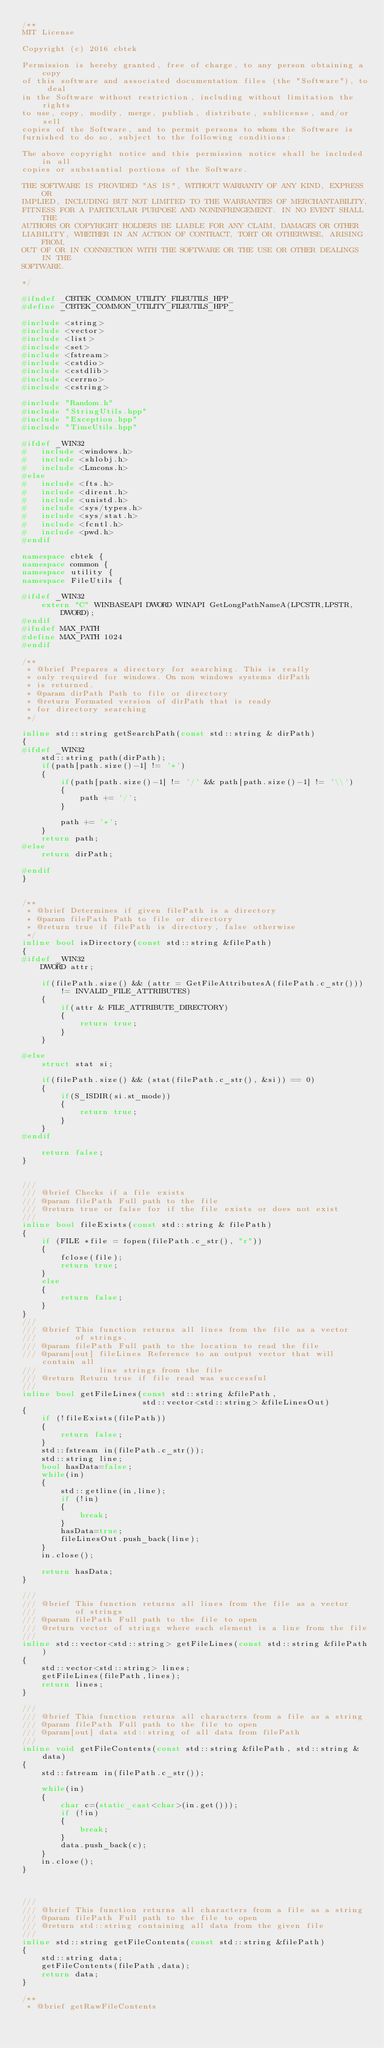<code> <loc_0><loc_0><loc_500><loc_500><_C++_>/**
MIT License

Copyright (c) 2016 cbtek

Permission is hereby granted, free of charge, to any person obtaining a copy
of this software and associated documentation files (the "Software"), to deal
in the Software without restriction, including without limitation the rights
to use, copy, modify, merge, publish, distribute, sublicense, and/or sell
copies of the Software, and to permit persons to whom the Software is
furnished to do so, subject to the following conditions:

The above copyright notice and this permission notice shall be included in all
copies or substantial portions of the Software.

THE SOFTWARE IS PROVIDED "AS IS", WITHOUT WARRANTY OF ANY KIND, EXPRESS OR
IMPLIED, INCLUDING BUT NOT LIMITED TO THE WARRANTIES OF MERCHANTABILITY,
FITNESS FOR A PARTICULAR PURPOSE AND NONINFRINGEMENT. IN NO EVENT SHALL THE
AUTHORS OR COPYRIGHT HOLDERS BE LIABLE FOR ANY CLAIM, DAMAGES OR OTHER
LIABILITY, WHETHER IN AN ACTION OF CONTRACT, TORT OR OTHERWISE, ARISING FROM,
OUT OF OR IN CONNECTION WITH THE SOFTWARE OR THE USE OR OTHER DEALINGS IN THE
SOFTWARE.

*/

#ifndef _CBTEK_COMMON_UTILITY_FILEUTILS_HPP_
#define _CBTEK_COMMON_UTILITY_FILEUTILS_HPP_

#include <string>
#include <vector>
#include <list>
#include <set>
#include <fstream>
#include <cstdio>
#include <cstdlib>
#include <cerrno>
#include <cstring>

#include "Random.h"
#include "StringUtils.hpp"
#include "Exception.hpp"
#include "TimeUtils.hpp"

#ifdef _WIN32
#   include <windows.h>
#   include <shlobj.h>
#   include <Lmcons.h>
#else
#   include <fts.h>
#   include <dirent.h>
#   include <unistd.h>
#   include <sys/types.h>
#   include <sys/stat.h>
#   include <fcntl.h>
#   include <pwd.h>
#endif

namespace cbtek {
namespace common {
namespace utility {
namespace FileUtils {

#ifdef _WIN32
    extern "C" WINBASEAPI DWORD WINAPI GetLongPathNameA(LPCSTR,LPSTR,DWORD);
#endif
#ifndef MAX_PATH
#define MAX_PATH 1024
#endif

/**
 * @brief Prepares a directory for searching. This is really
 * only required for windows. On non windows systems dirPath
 * is returned.
 * @param dirPath Path to file or directory
 * @return Formated version of dirPath that is ready
 * for directory searching
 */

inline std::string getSearchPath(const std::string & dirPath)
{
#ifdef _WIN32
    std::string path(dirPath);
    if(path[path.size()-1] != '*')
    {
        if(path[path.size()-1] != '/' && path[path.size()-1] != '\\')
        {
            path += '/';
        }

        path += '*';
    }
    return path;
#else
    return dirPath;

#endif
}


/**
 * @brief Determines if given filePath is a directory
 * @param filePath Path to file or directory
 * @return true if filePath is directory, false otherwise
 */
inline bool isDirectory(const std::string &filePath)
{
#ifdef _WIN32
    DWORD attr;

    if(filePath.size() && (attr = GetFileAttributesA(filePath.c_str())) != INVALID_FILE_ATTRIBUTES)
    {
        if(attr & FILE_ATTRIBUTE_DIRECTORY)
        {
            return true;
        }
    }

#else
    struct stat si;

    if(filePath.size() && (stat(filePath.c_str(), &si)) == 0)
    {
        if(S_ISDIR(si.st_mode))
        {
            return true;
        }
    }
#endif

    return false;
}


///
/// @brief Checks if a file exists
/// @param filePath Full path to the file
/// @return true or false for if the file exists or does not exist
///
inline bool fileExists(const std::string & filePath)
{
    if (FILE *file = fopen(filePath.c_str(), "r"))
    {
        fclose(file);
        return true;
    }
    else
    {
        return false;
    }
}
///
/// @brief This function returns all lines from the file as a vector
///        of strings.
/// @param filePath Full path to the location to read the file
/// @param[out] fileLines Reference to an output vector that will contain all
///             line strings from the file
/// @return Return true if file read was successful
///
inline bool getFileLines(const std::string &filePath,
                         std::vector<std::string> &fileLinesOut)
{
    if (!fileExists(filePath))
    {
        return false;
    }
    std::fstream in(filePath.c_str());
    std::string line;
    bool hasData=false;
    while(in)
    {
        std::getline(in,line);
        if (!in)
        {
            break;
        }
        hasData=true;
        fileLinesOut.push_back(line);
    }
    in.close();

    return hasData;
}

///
/// @brief This function returns all lines from the file as a vector
///        of strings
/// @param filePath Full path to the file to open
/// @return vector of strings where each element is a line from the file
///
inline std::vector<std::string> getFileLines(const std::string &filePath)
{
    std::vector<std::string> lines;
    getFileLines(filePath,lines);
    return lines;
}

///
/// @brief This function returns all characters from a file as a string
/// @param filePath Full path to the file to open
/// @param[out] data std::string of all data from filePath
///
inline void getFileContents(const std::string &filePath, std::string &data)
{
    std::fstream in(filePath.c_str());

    while(in)
    {
        char c=(static_cast<char>(in.get()));
        if (!in)
        {
            break;
        }
        data.push_back(c);
    }
    in.close();
}



///
/// @brief This function returns all characters from a file as a string
/// @param filePath Full path to the file to open
/// @return std::string containing all data from the given file
///
inline std::string getFileContents(const std::string &filePath)
{
    std::string data;
    getFileContents(filePath,data);
    return data;
}

/**
 * @brief getRawFileContents</code> 